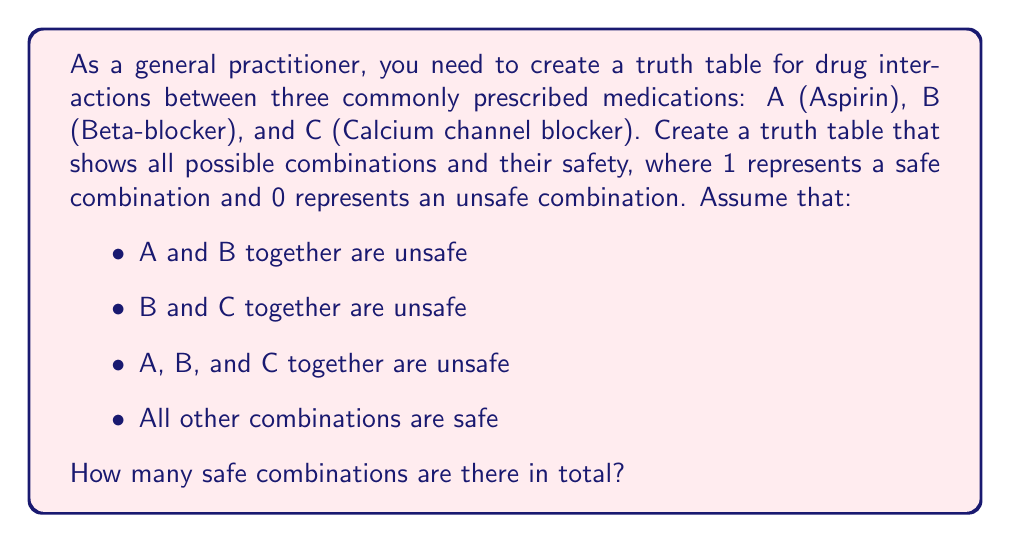What is the answer to this math problem? Let's approach this step-by-step:

1) First, we need to create the truth table. With three variables (A, B, C), we'll have $2^3 = 8$ possible combinations.

2) Let's create the table:

   A | B | C | Safe
   ----------------
   0 | 0 | 0 |  1
   0 | 0 | 1 |  1
   0 | 1 | 0 |  1
   0 | 1 | 1 |  0
   1 | 0 | 0 |  1
   1 | 0 | 1 |  1
   1 | 1 | 0 |  0
   1 | 1 | 1 |  0

3) The safety column is determined by the following Boolean expression:
   $$ \text{Safe} = \overline{(A \cdot B)} \cdot \overline{(B \cdot C)} \cdot \overline{(A \cdot B \cdot C)} $$

4) This can be read as: It's safe if it's not (A and B) AND not (B and C) AND not (A and B and C).

5) Now, we simply count the number of 1's in the "Safe" column.

6) We can see that there are 5 safe combinations (rows where "Safe" is 1).

Therefore, there are 5 safe combinations in total.
Answer: 5 